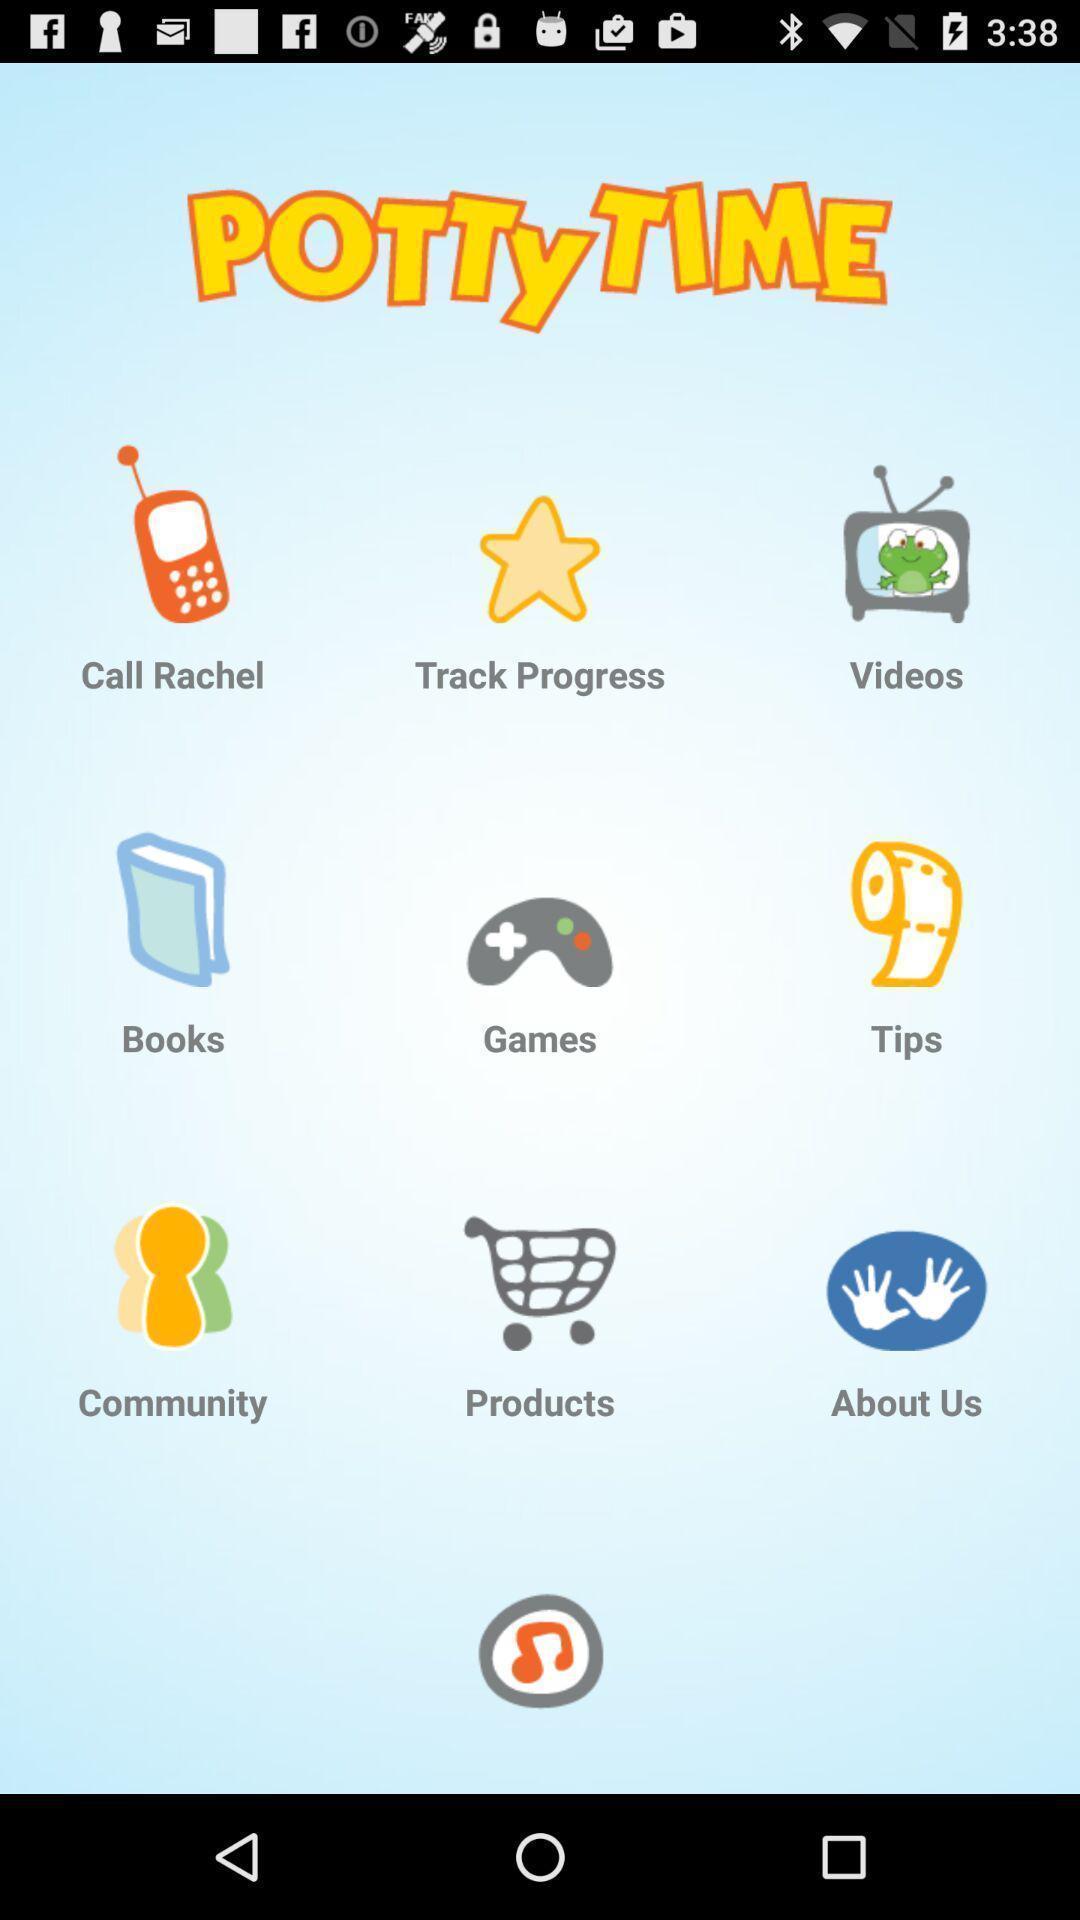Describe the key features of this screenshot. Screen showing about potty time. 